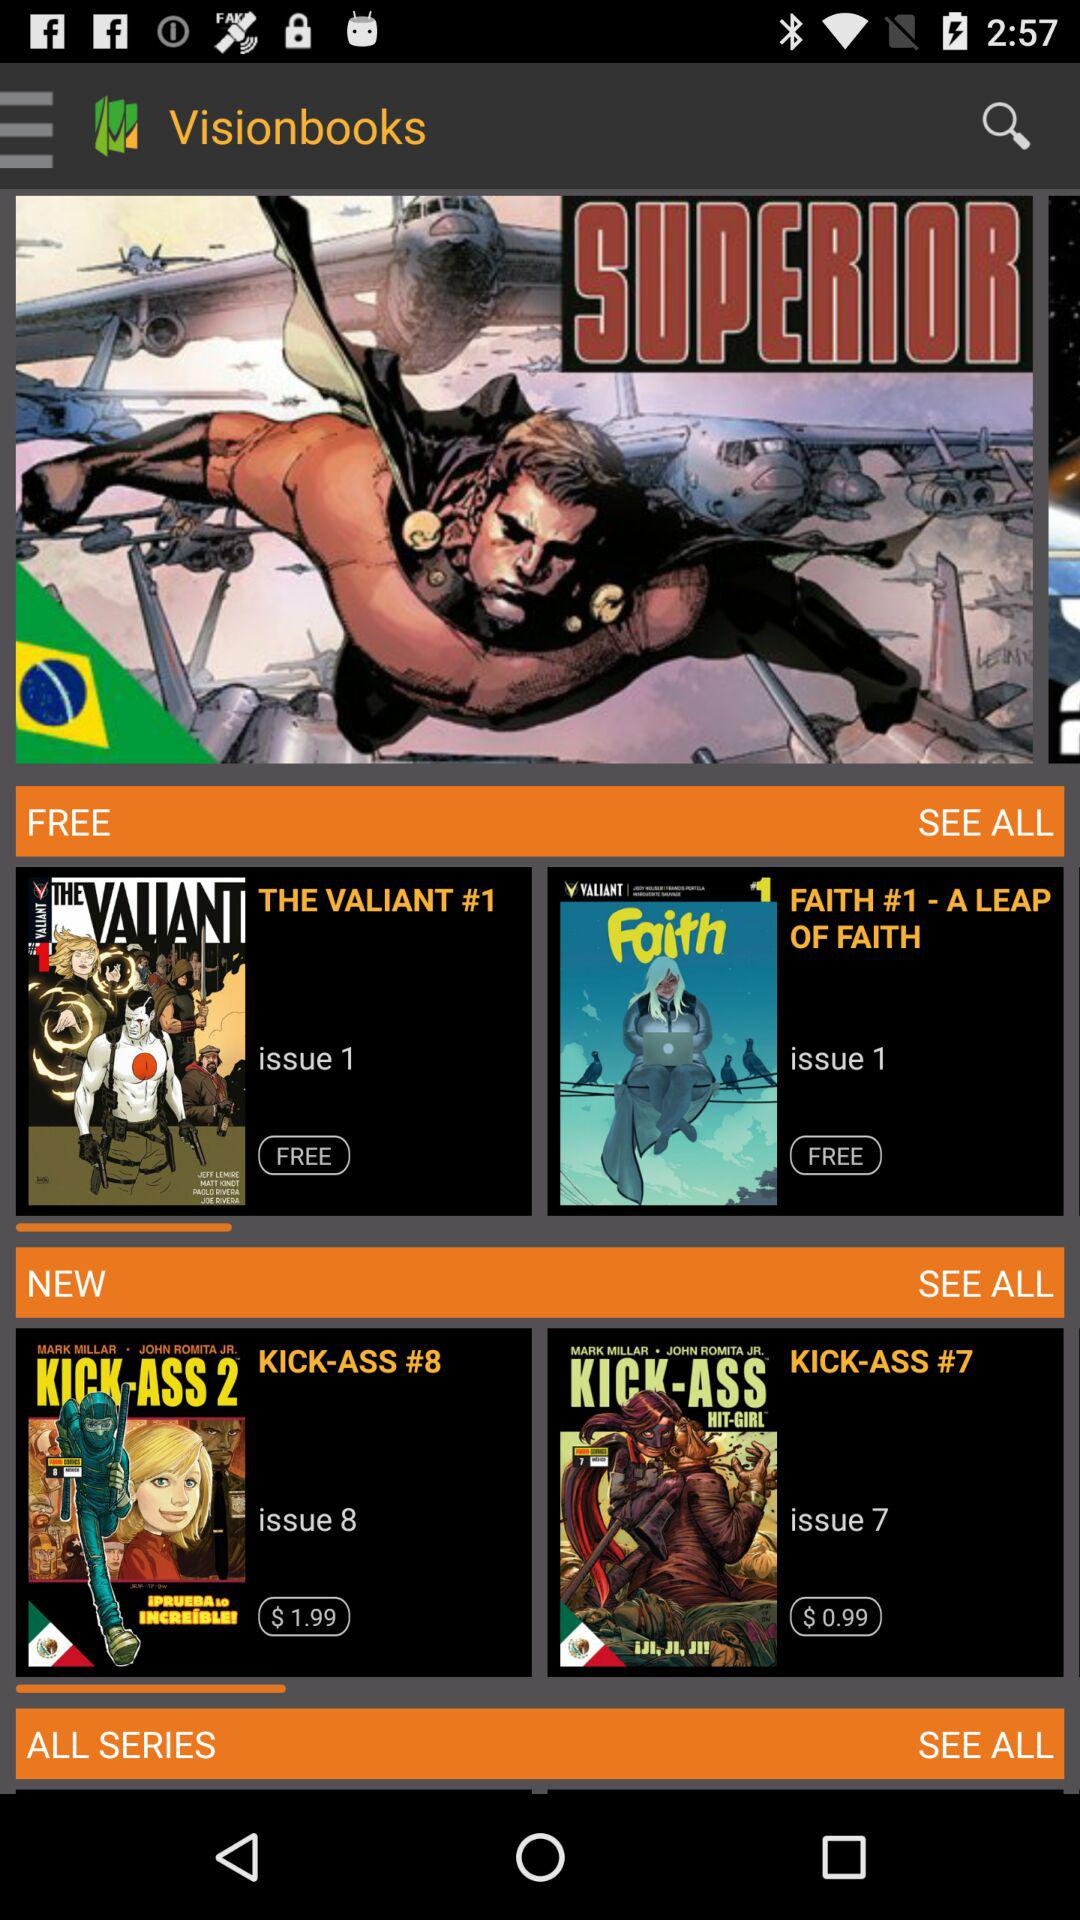Which book price is $0.99? The book whose price is $0.99 is "KICK-ASS #7". 